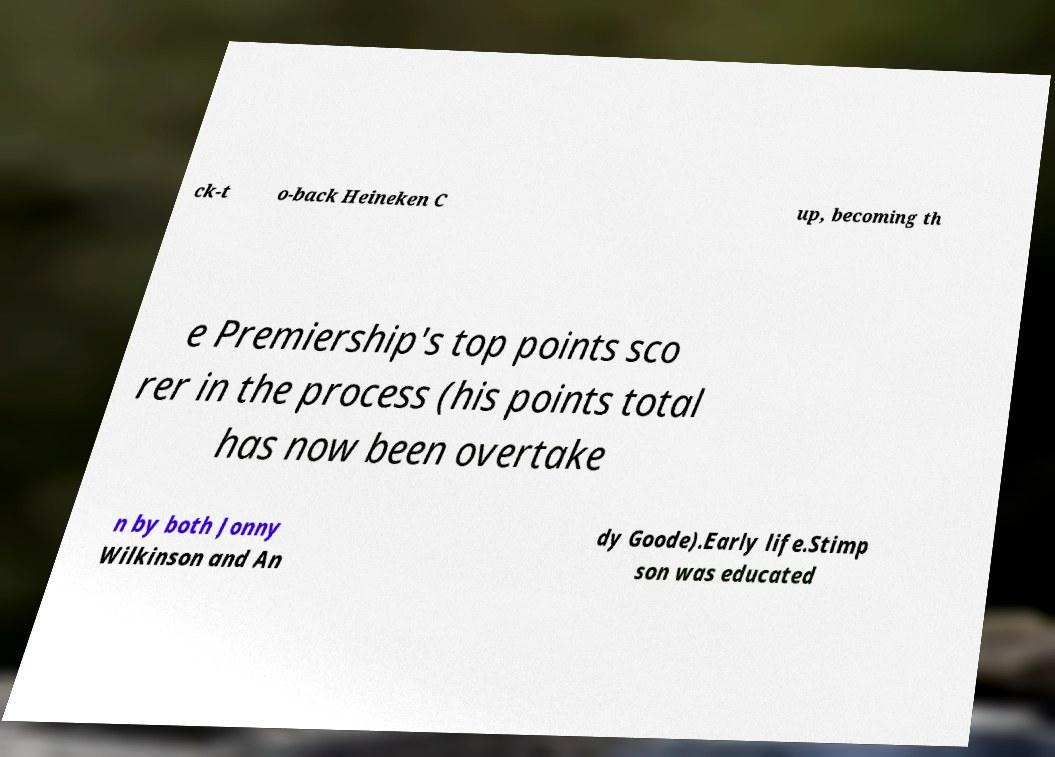Can you read and provide the text displayed in the image?This photo seems to have some interesting text. Can you extract and type it out for me? ck-t o-back Heineken C up, becoming th e Premiership's top points sco rer in the process (his points total has now been overtake n by both Jonny Wilkinson and An dy Goode).Early life.Stimp son was educated 